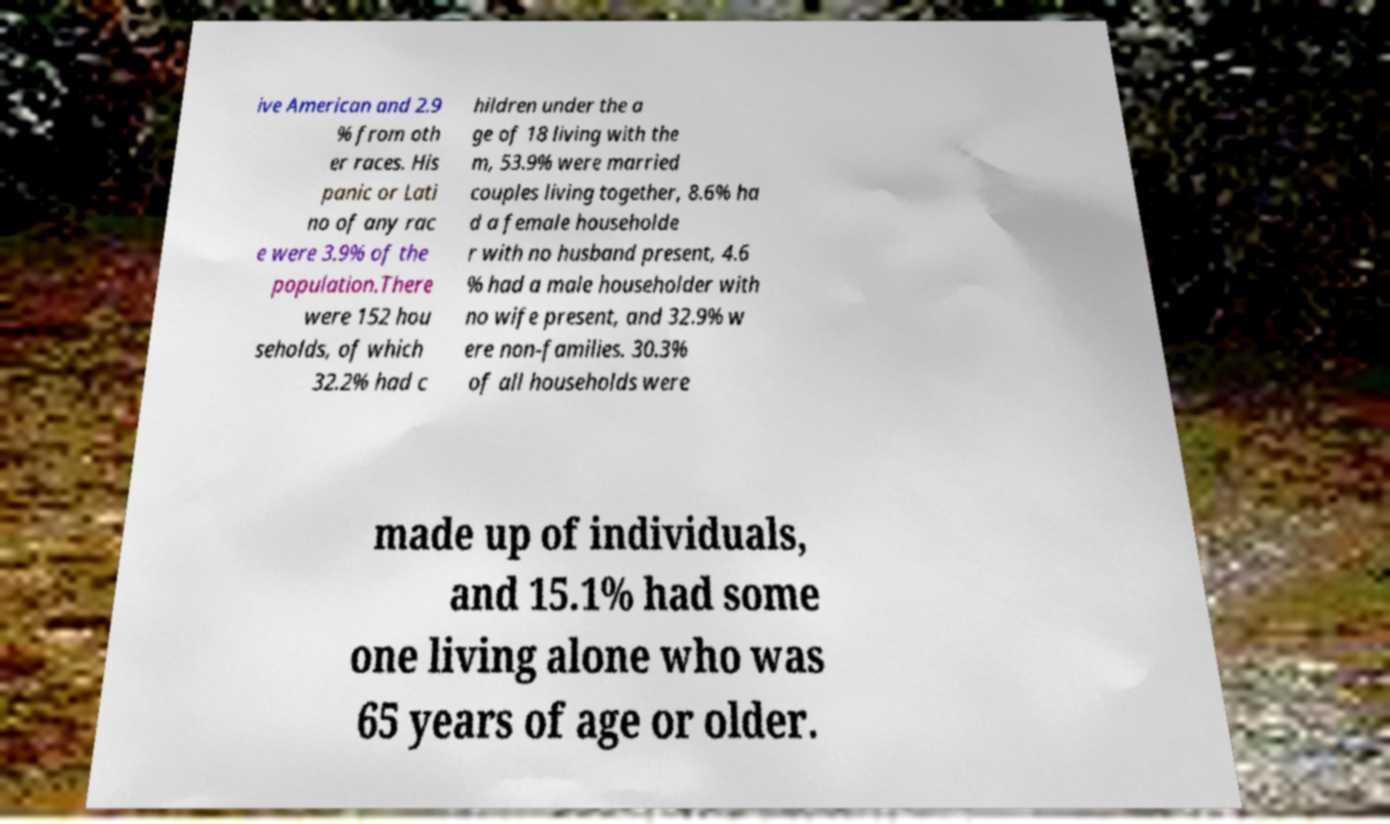I need the written content from this picture converted into text. Can you do that? ive American and 2.9 % from oth er races. His panic or Lati no of any rac e were 3.9% of the population.There were 152 hou seholds, of which 32.2% had c hildren under the a ge of 18 living with the m, 53.9% were married couples living together, 8.6% ha d a female householde r with no husband present, 4.6 % had a male householder with no wife present, and 32.9% w ere non-families. 30.3% of all households were made up of individuals, and 15.1% had some one living alone who was 65 years of age or older. 